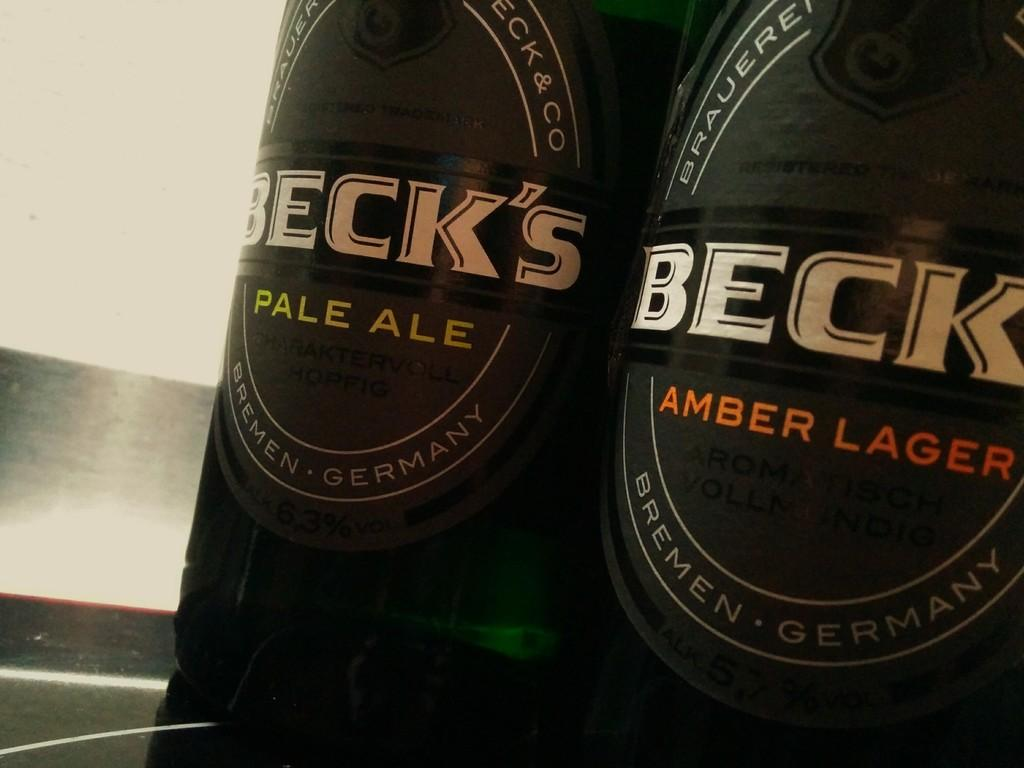<image>
Write a terse but informative summary of the picture. A bottle of Beck's Pale Ale and Beck's Amber Lager are side by side. 